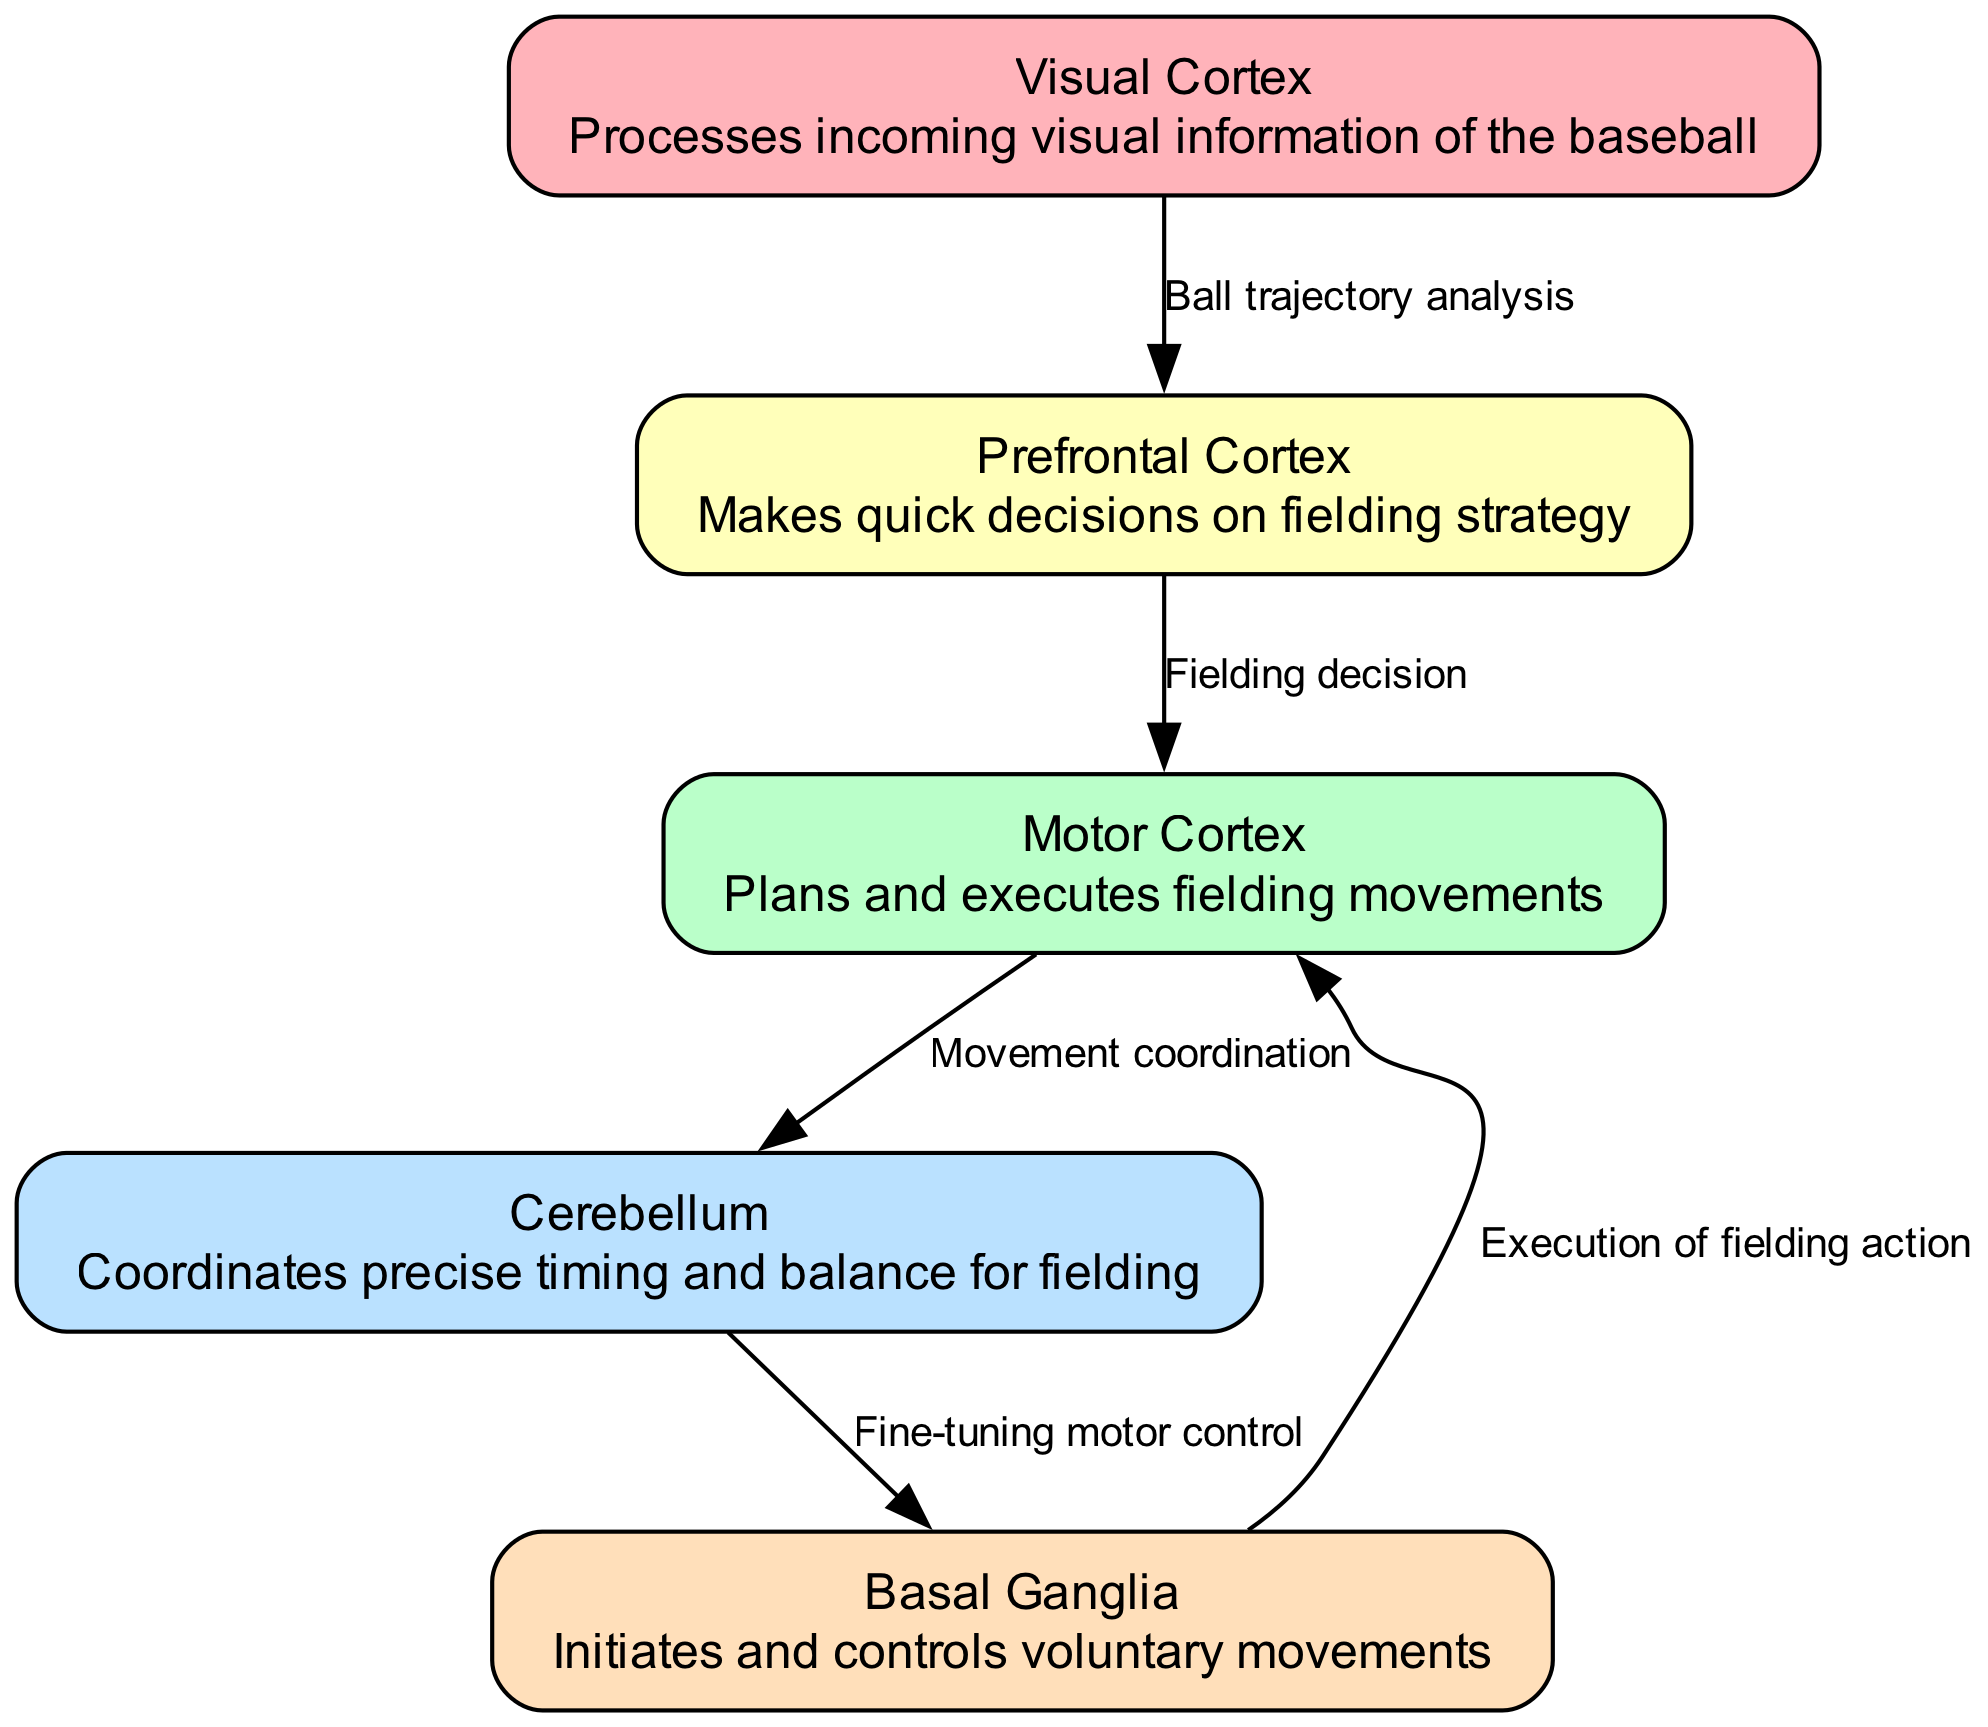What are the nodes in this diagram? The nodes in the diagram are the key parts of the brain involved in the fielding process: Visual Cortex, Motor Cortex, Cerebellum, Prefrontal Cortex, and Basal Ganglia. Each node represents a specific brain function related to reaction time and decision-making in baseball.
Answer: Visual Cortex, Motor Cortex, Cerebellum, Prefrontal Cortex, Basal Ganglia How many edges are there in the diagram? The edges represent the relationships between the various brain functions. When counting the edges between nodes, there are five connections illustrated.
Answer: 5 What is the function of the Precortex? The Prefrontal Cortex is responsible for making quick decisions on fielding strategy, allowing the player to react effectively during a game situation, showing its critical role in instantaneous decision-making.
Answer: Makes quick decisions on fielding strategy Which node processes visual information of the baseball? The node responsible for processing incoming visual information related to the baseball is the Visual Cortex, whose primary task involves analyzing visual cues such as the ball's trajectory.
Answer: Visual Cortex What flow of information occurs from the Visual Cortex to the Motor Cortex? The flow of information starts with the Visual Cortex analyzing the ball's trajectory, which is then sent to the Prefrontal Cortex for decision-making. This decision is subsequently communicated to the Motor Cortex to plan and execute the actual fielding movements.
Answer: Visual Cortex to Prefrontal Cortex to Motor Cortex What role does the Cerebellum play in this reaction sequence? The Cerebellum coordinates precise timing and balance for fielding. It ensures that the planned movements from the Motor Cortex are executed accurately, allowing for effective fielding actions.
Answer: Coordinates precise timing and balance for fielding How does the Basal Ganglia contribute to the execution of movements? The Basal Ganglia receives fine-tuning inputs from the Cerebellum, and its role is critical as it helps initiate and control the voluntary movements needed during fielding, ensuring that the execution of the fielding action is smooth and coordinated.
Answer: Initiates and controls voluntary movements What is the initial step in the diagram's processing sequence? The initial step in the processing sequence starts with the Visual Cortex, which analyzes the trajectory of the baseball. This sets the entire reaction process into motion, leading to decision-making and eventual fielding actions.
Answer: Visual Cortex 